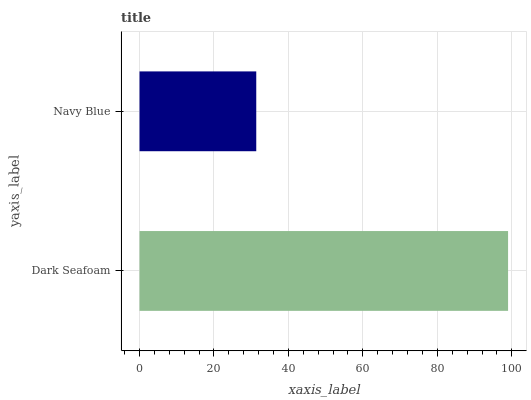Is Navy Blue the minimum?
Answer yes or no. Yes. Is Dark Seafoam the maximum?
Answer yes or no. Yes. Is Navy Blue the maximum?
Answer yes or no. No. Is Dark Seafoam greater than Navy Blue?
Answer yes or no. Yes. Is Navy Blue less than Dark Seafoam?
Answer yes or no. Yes. Is Navy Blue greater than Dark Seafoam?
Answer yes or no. No. Is Dark Seafoam less than Navy Blue?
Answer yes or no. No. Is Dark Seafoam the high median?
Answer yes or no. Yes. Is Navy Blue the low median?
Answer yes or no. Yes. Is Navy Blue the high median?
Answer yes or no. No. Is Dark Seafoam the low median?
Answer yes or no. No. 